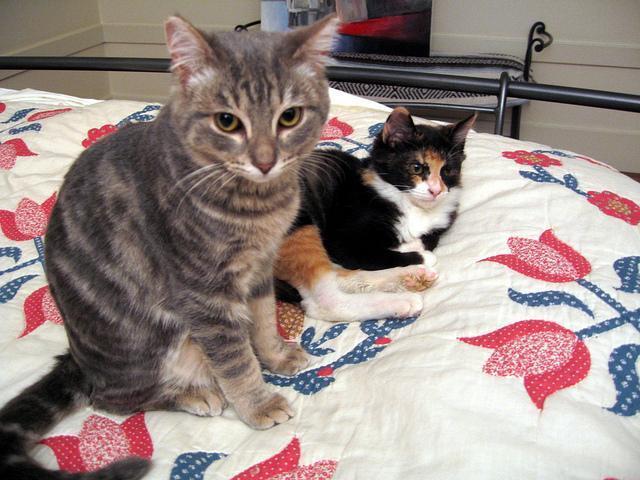How many cats are there?
Give a very brief answer. 2. 